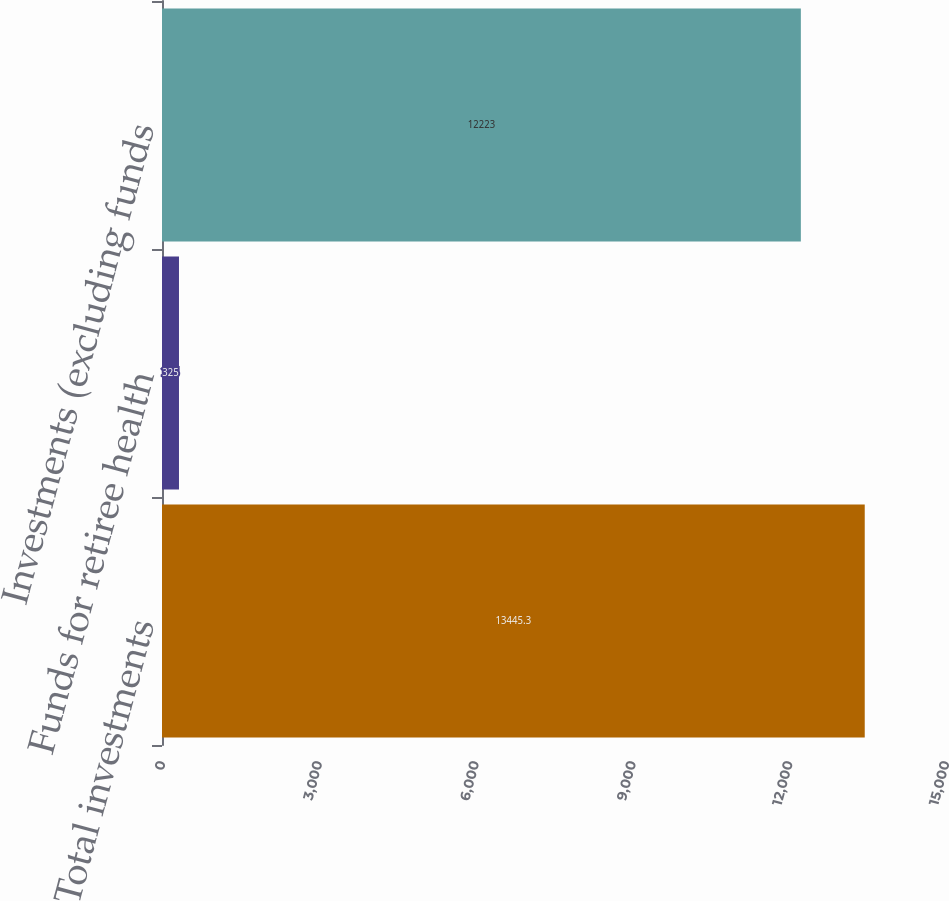Convert chart to OTSL. <chart><loc_0><loc_0><loc_500><loc_500><bar_chart><fcel>Total investments<fcel>Funds for retiree health<fcel>Investments (excluding funds<nl><fcel>13445.3<fcel>325<fcel>12223<nl></chart> 